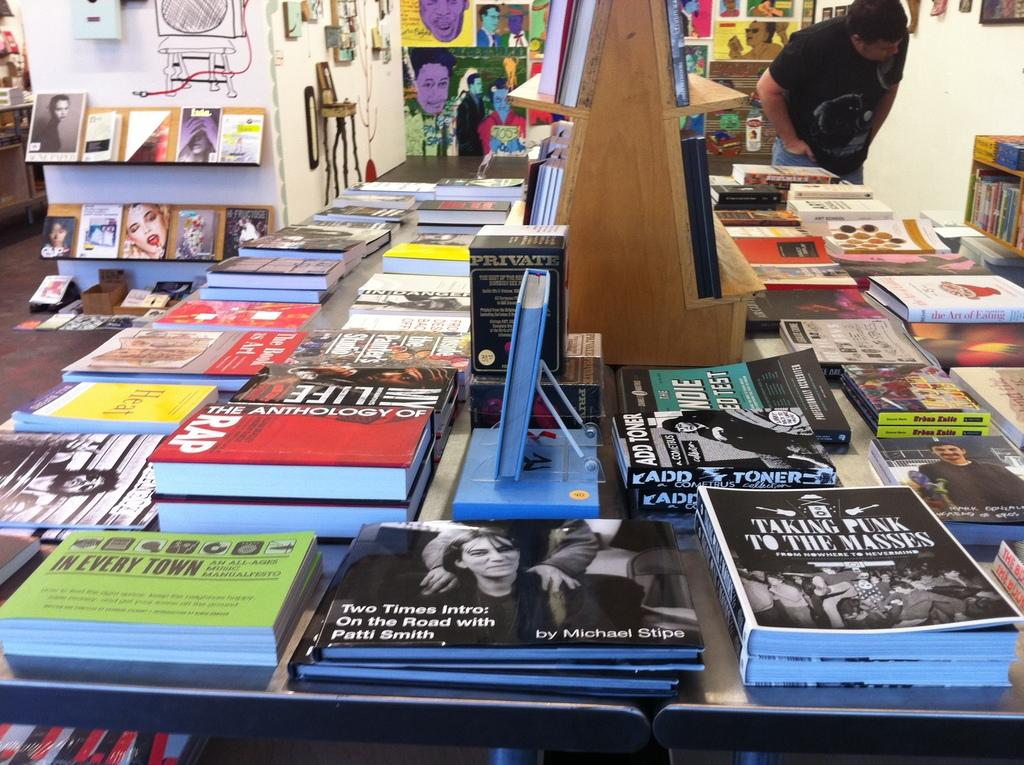What is the primary subject of the image? The primary subject of the image is many books. Where are the books located in the image? The books are placed on a table in the image. What type of robin can be seen wearing apparel in the image? There is no robin or apparel present in the image; it only features books on a table. 